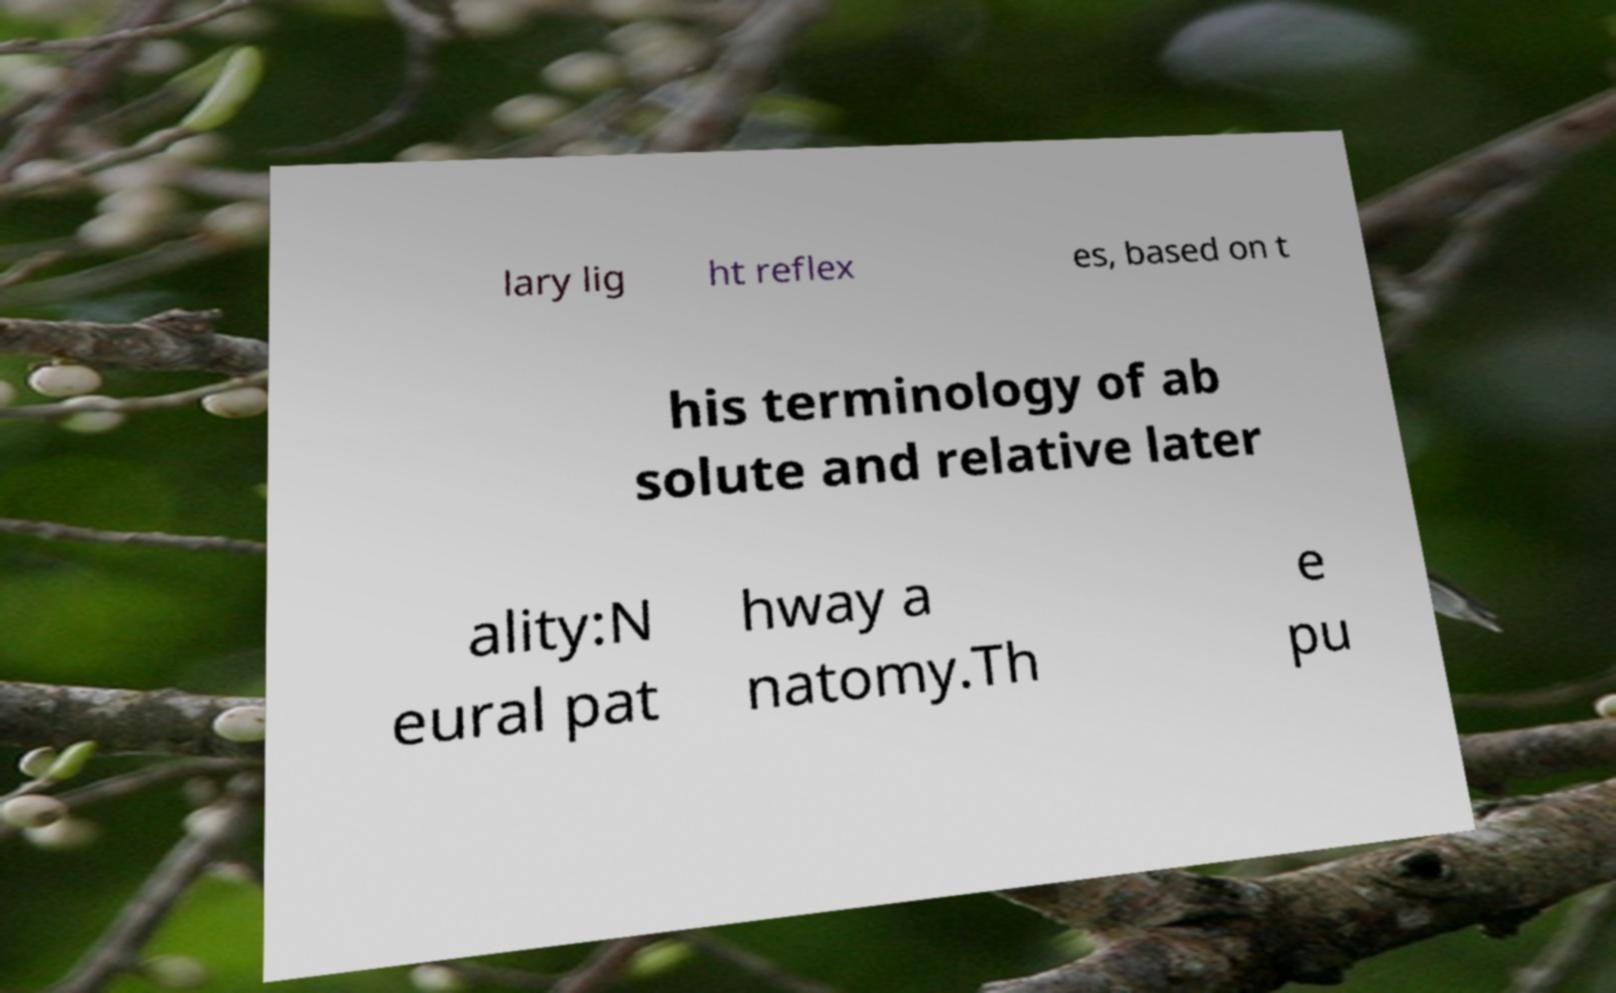Could you extract and type out the text from this image? lary lig ht reflex es, based on t his terminology of ab solute and relative later ality:N eural pat hway a natomy.Th e pu 